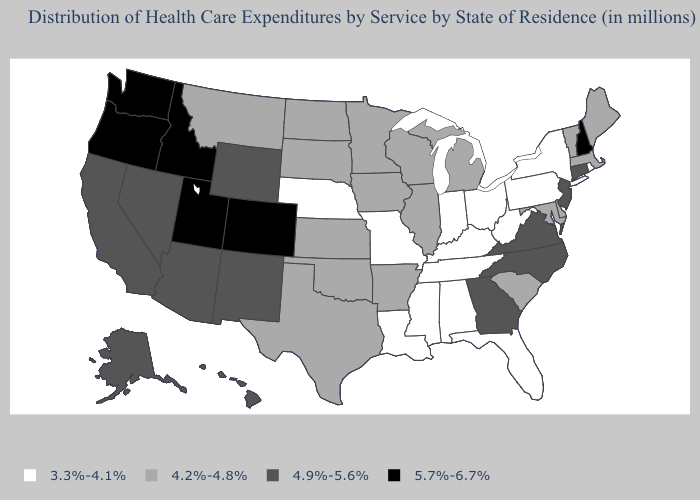What is the value of Indiana?
Give a very brief answer. 3.3%-4.1%. Does South Carolina have a lower value than South Dakota?
Write a very short answer. No. What is the value of Rhode Island?
Be succinct. 3.3%-4.1%. Among the states that border Arizona , which have the highest value?
Be succinct. Colorado, Utah. Among the states that border West Virginia , does Virginia have the highest value?
Quick response, please. Yes. Among the states that border Nevada , which have the lowest value?
Short answer required. Arizona, California. Which states have the lowest value in the South?
Quick response, please. Alabama, Florida, Kentucky, Louisiana, Mississippi, Tennessee, West Virginia. Name the states that have a value in the range 4.9%-5.6%?
Short answer required. Alaska, Arizona, California, Connecticut, Georgia, Hawaii, Nevada, New Jersey, New Mexico, North Carolina, Virginia, Wyoming. Among the states that border Oklahoma , which have the lowest value?
Short answer required. Missouri. Among the states that border Maryland , which have the highest value?
Answer briefly. Virginia. Is the legend a continuous bar?
Answer briefly. No. Name the states that have a value in the range 4.9%-5.6%?
Keep it brief. Alaska, Arizona, California, Connecticut, Georgia, Hawaii, Nevada, New Jersey, New Mexico, North Carolina, Virginia, Wyoming. Does Oregon have the highest value in the USA?
Give a very brief answer. Yes. Among the states that border Indiana , does Ohio have the lowest value?
Be succinct. Yes. Does the first symbol in the legend represent the smallest category?
Give a very brief answer. Yes. 